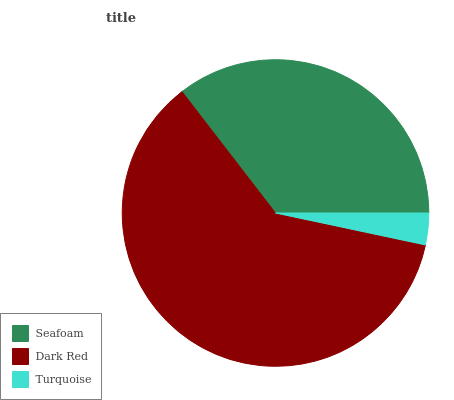Is Turquoise the minimum?
Answer yes or no. Yes. Is Dark Red the maximum?
Answer yes or no. Yes. Is Dark Red the minimum?
Answer yes or no. No. Is Turquoise the maximum?
Answer yes or no. No. Is Dark Red greater than Turquoise?
Answer yes or no. Yes. Is Turquoise less than Dark Red?
Answer yes or no. Yes. Is Turquoise greater than Dark Red?
Answer yes or no. No. Is Dark Red less than Turquoise?
Answer yes or no. No. Is Seafoam the high median?
Answer yes or no. Yes. Is Seafoam the low median?
Answer yes or no. Yes. Is Turquoise the high median?
Answer yes or no. No. Is Dark Red the low median?
Answer yes or no. No. 